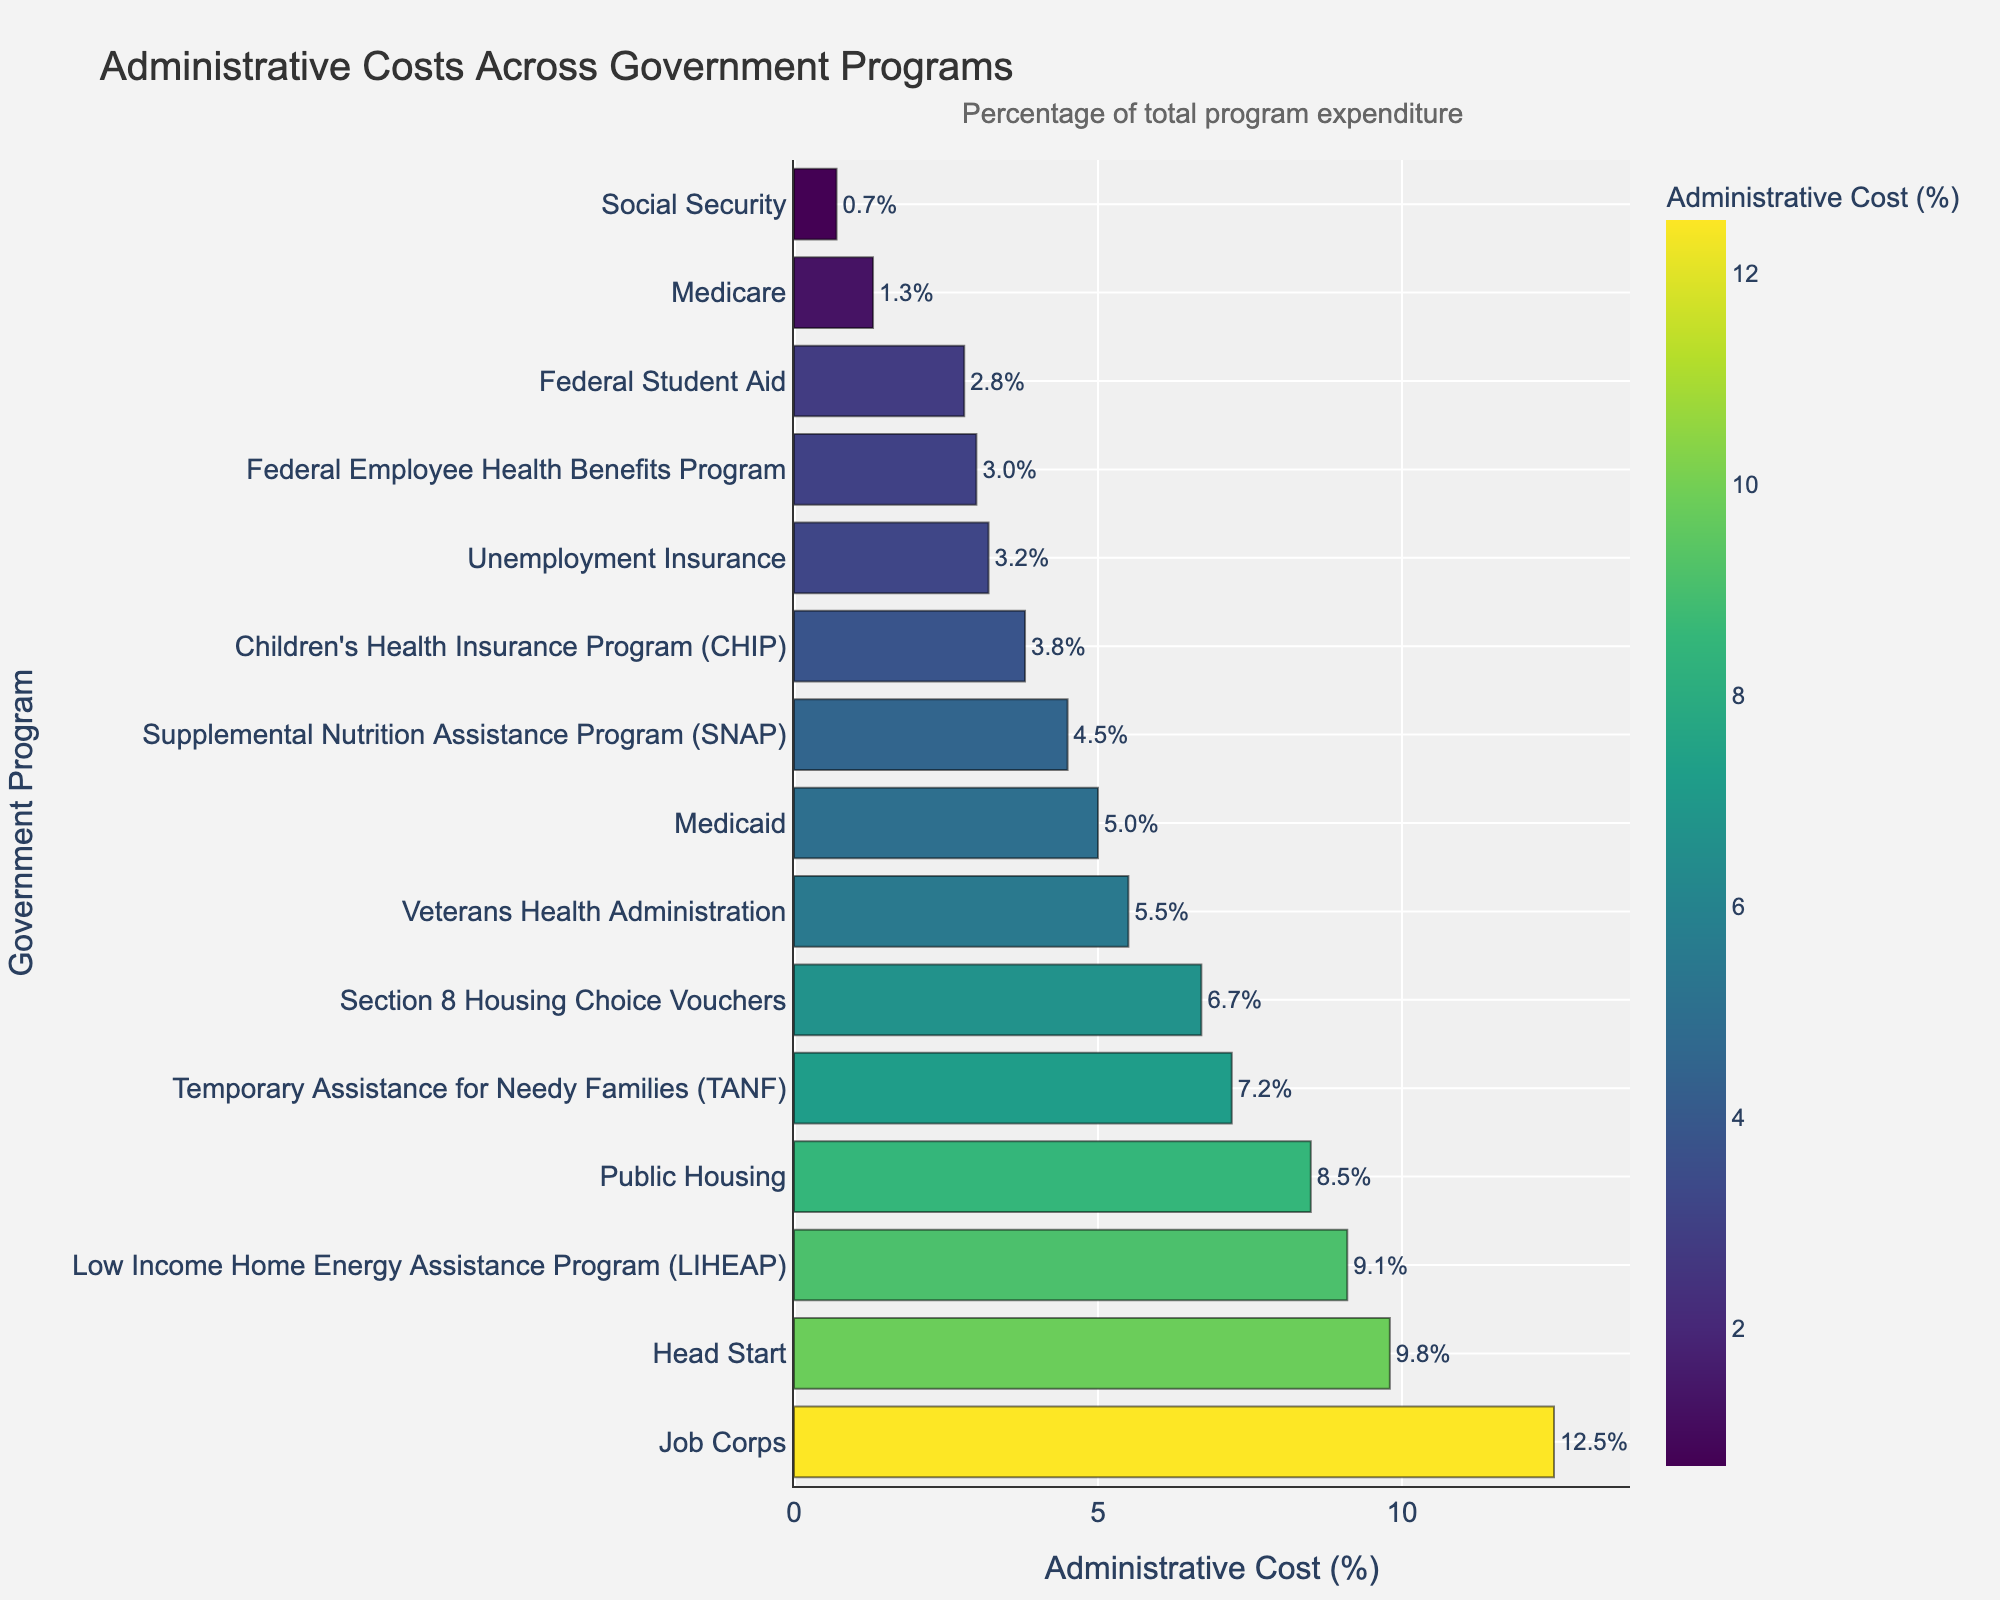What is the program with the highest administrative cost percentage? The program with the highest bar and hence the highest value on the x-axis represents the highest administrative cost percentage.
Answer: Job Corps Which program has a lower administrative cost percentage, SNAP or Unemployment Insurance? Find the bars for SNAP and Unemployment Insurance and compare their lengths. Unemployment Insurance has a shorter bar.
Answer: Unemployment Insurance What is the combined administrative cost percentage of TANF and Job Corps? Look for the lengths of the bars for TANF and Job Corps, then add their values: 7.2% + 12.5% = 19.7%.
Answer: 19.7% Which programs have an administrative cost percentage over 8%? Identify all bars with lengths exceeding the 8% mark on the x-axis. These are LIHEAP, Public Housing, Job Corps, and Head Start.
Answer: LIHEAP, Public Housing, Job Corps, Head Start How much lower is the administrative cost percentage of CHIP compared to Public Housing? Find and subtract the administrative cost percentages for CHIP (3.8%) and Public Housing (8.5%): 8.5% - 3.8% = 4.7%.
Answer: 4.7% What is the average administrative cost percentage of Medicare, Medicaid, and CHIP? Add the percentages for Medicare (1.3%), Medicaid (5.0%), and CHIP (3.8%), then divide by 3: (1.3 + 5.0 + 3.8) / 3 = 3.37%.
Answer: 3.37% Which program has the second-lowest administrative cost percentage? Rank the bars by their lengths in ascending order. The second-lowest bar after Social Security (0.7%) is Medicare (1.3%).
Answer: Medicare Which program has a higher administrative cost percentage, Children’s Health Insurance Program or Federal Employee Health Benefits Program? Compare the lengths of the bars for CHIP and Federal Employee Health Benefits. CHIP has a longer bar.
Answer: Children’s Health Insurance Program 